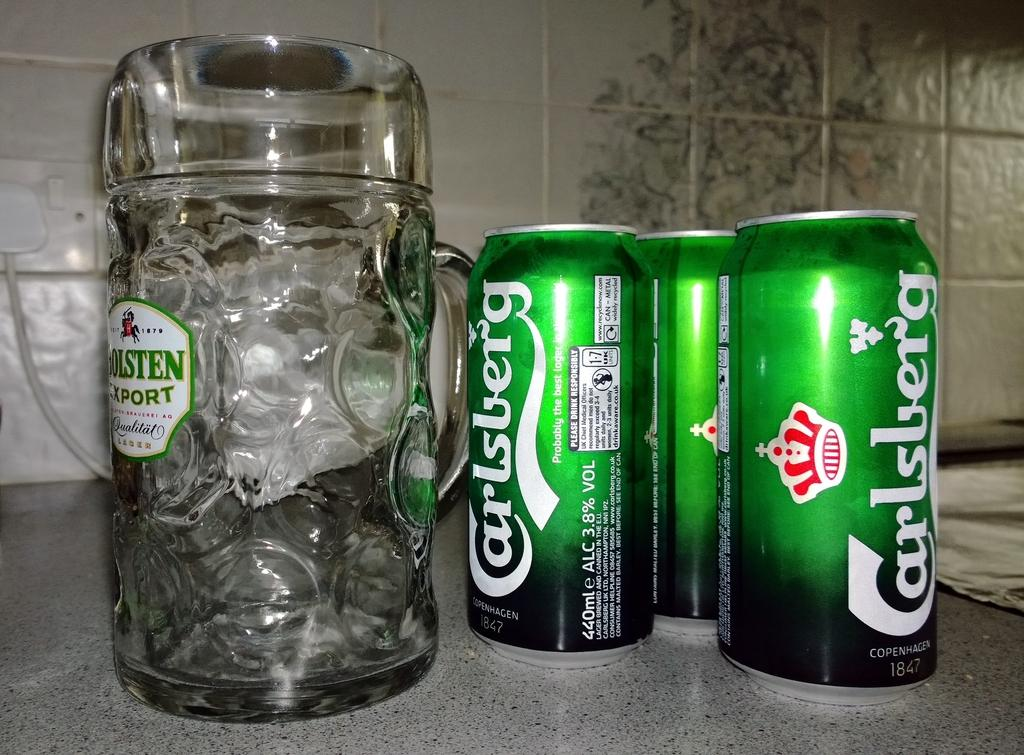Provide a one-sentence caption for the provided image. Three green cans of Carlsburg next to a glass stein. 